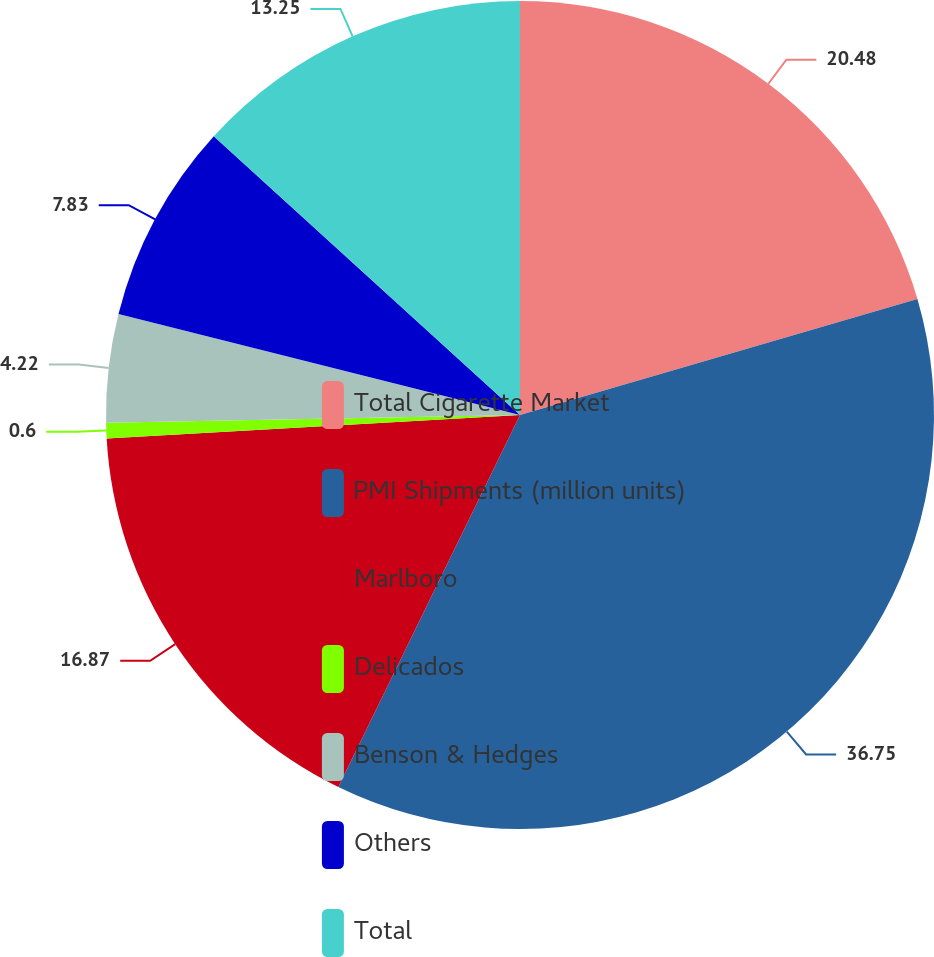Convert chart to OTSL. <chart><loc_0><loc_0><loc_500><loc_500><pie_chart><fcel>Total Cigarette Market<fcel>PMI Shipments (million units)<fcel>Marlboro<fcel>Delicados<fcel>Benson & Hedges<fcel>Others<fcel>Total<nl><fcel>20.48%<fcel>36.75%<fcel>16.87%<fcel>0.6%<fcel>4.22%<fcel>7.83%<fcel>13.25%<nl></chart> 